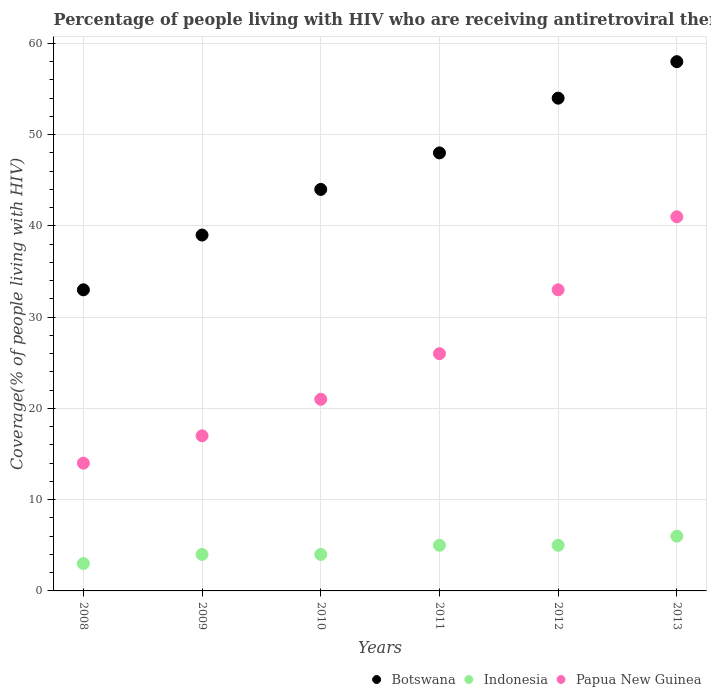How many different coloured dotlines are there?
Give a very brief answer. 3. What is the percentage of the HIV infected people who are receiving antiretroviral therapy in Indonesia in 2011?
Give a very brief answer. 5. Across all years, what is the maximum percentage of the HIV infected people who are receiving antiretroviral therapy in Papua New Guinea?
Provide a succinct answer. 41. Across all years, what is the minimum percentage of the HIV infected people who are receiving antiretroviral therapy in Indonesia?
Give a very brief answer. 3. What is the total percentage of the HIV infected people who are receiving antiretroviral therapy in Botswana in the graph?
Offer a very short reply. 276. What is the difference between the percentage of the HIV infected people who are receiving antiretroviral therapy in Indonesia in 2008 and that in 2012?
Offer a terse response. -2. What is the difference between the percentage of the HIV infected people who are receiving antiretroviral therapy in Indonesia in 2011 and the percentage of the HIV infected people who are receiving antiretroviral therapy in Botswana in 2010?
Ensure brevity in your answer.  -39. In the year 2008, what is the difference between the percentage of the HIV infected people who are receiving antiretroviral therapy in Indonesia and percentage of the HIV infected people who are receiving antiretroviral therapy in Botswana?
Offer a terse response. -30. What is the ratio of the percentage of the HIV infected people who are receiving antiretroviral therapy in Papua New Guinea in 2008 to that in 2010?
Your answer should be very brief. 0.67. Is the percentage of the HIV infected people who are receiving antiretroviral therapy in Botswana in 2010 less than that in 2011?
Ensure brevity in your answer.  Yes. Is the difference between the percentage of the HIV infected people who are receiving antiretroviral therapy in Indonesia in 2008 and 2009 greater than the difference between the percentage of the HIV infected people who are receiving antiretroviral therapy in Botswana in 2008 and 2009?
Offer a very short reply. Yes. What is the difference between the highest and the second highest percentage of the HIV infected people who are receiving antiretroviral therapy in Indonesia?
Ensure brevity in your answer.  1. What is the difference between the highest and the lowest percentage of the HIV infected people who are receiving antiretroviral therapy in Papua New Guinea?
Ensure brevity in your answer.  27. In how many years, is the percentage of the HIV infected people who are receiving antiretroviral therapy in Indonesia greater than the average percentage of the HIV infected people who are receiving antiretroviral therapy in Indonesia taken over all years?
Keep it short and to the point. 3. Is the sum of the percentage of the HIV infected people who are receiving antiretroviral therapy in Indonesia in 2009 and 2010 greater than the maximum percentage of the HIV infected people who are receiving antiretroviral therapy in Botswana across all years?
Offer a terse response. No. How many years are there in the graph?
Provide a short and direct response. 6. What is the difference between two consecutive major ticks on the Y-axis?
Your answer should be very brief. 10. Does the graph contain any zero values?
Your response must be concise. No. Where does the legend appear in the graph?
Your answer should be very brief. Bottom right. How many legend labels are there?
Offer a very short reply. 3. What is the title of the graph?
Your answer should be compact. Percentage of people living with HIV who are receiving antiretroviral therapy. Does "Costa Rica" appear as one of the legend labels in the graph?
Your answer should be compact. No. What is the label or title of the X-axis?
Provide a short and direct response. Years. What is the label or title of the Y-axis?
Offer a terse response. Coverage(% of people living with HIV). What is the Coverage(% of people living with HIV) of Botswana in 2008?
Keep it short and to the point. 33. What is the Coverage(% of people living with HIV) of Indonesia in 2008?
Offer a terse response. 3. What is the Coverage(% of people living with HIV) of Botswana in 2009?
Your response must be concise. 39. What is the Coverage(% of people living with HIV) of Indonesia in 2009?
Keep it short and to the point. 4. What is the Coverage(% of people living with HIV) in Botswana in 2010?
Your response must be concise. 44. What is the Coverage(% of people living with HIV) of Botswana in 2011?
Make the answer very short. 48. What is the Coverage(% of people living with HIV) in Botswana in 2012?
Make the answer very short. 54. What is the Coverage(% of people living with HIV) in Indonesia in 2012?
Keep it short and to the point. 5. What is the Coverage(% of people living with HIV) in Botswana in 2013?
Ensure brevity in your answer.  58. What is the Coverage(% of people living with HIV) in Indonesia in 2013?
Provide a short and direct response. 6. What is the Coverage(% of people living with HIV) in Papua New Guinea in 2013?
Your answer should be compact. 41. Across all years, what is the maximum Coverage(% of people living with HIV) in Botswana?
Your answer should be very brief. 58. Across all years, what is the minimum Coverage(% of people living with HIV) of Indonesia?
Provide a succinct answer. 3. What is the total Coverage(% of people living with HIV) in Botswana in the graph?
Provide a succinct answer. 276. What is the total Coverage(% of people living with HIV) in Papua New Guinea in the graph?
Offer a very short reply. 152. What is the difference between the Coverage(% of people living with HIV) in Indonesia in 2008 and that in 2010?
Keep it short and to the point. -1. What is the difference between the Coverage(% of people living with HIV) in Papua New Guinea in 2008 and that in 2011?
Your answer should be very brief. -12. What is the difference between the Coverage(% of people living with HIV) of Indonesia in 2008 and that in 2012?
Give a very brief answer. -2. What is the difference between the Coverage(% of people living with HIV) in Papua New Guinea in 2008 and that in 2012?
Your answer should be compact. -19. What is the difference between the Coverage(% of people living with HIV) of Indonesia in 2008 and that in 2013?
Your answer should be very brief. -3. What is the difference between the Coverage(% of people living with HIV) of Papua New Guinea in 2008 and that in 2013?
Give a very brief answer. -27. What is the difference between the Coverage(% of people living with HIV) of Botswana in 2009 and that in 2010?
Provide a succinct answer. -5. What is the difference between the Coverage(% of people living with HIV) of Botswana in 2009 and that in 2011?
Give a very brief answer. -9. What is the difference between the Coverage(% of people living with HIV) in Papua New Guinea in 2009 and that in 2011?
Provide a short and direct response. -9. What is the difference between the Coverage(% of people living with HIV) in Papua New Guinea in 2009 and that in 2012?
Offer a very short reply. -16. What is the difference between the Coverage(% of people living with HIV) of Botswana in 2009 and that in 2013?
Make the answer very short. -19. What is the difference between the Coverage(% of people living with HIV) of Botswana in 2010 and that in 2012?
Your answer should be compact. -10. What is the difference between the Coverage(% of people living with HIV) of Indonesia in 2010 and that in 2012?
Give a very brief answer. -1. What is the difference between the Coverage(% of people living with HIV) in Indonesia in 2010 and that in 2013?
Offer a very short reply. -2. What is the difference between the Coverage(% of people living with HIV) in Botswana in 2011 and that in 2012?
Provide a short and direct response. -6. What is the difference between the Coverage(% of people living with HIV) in Papua New Guinea in 2011 and that in 2012?
Your answer should be very brief. -7. What is the difference between the Coverage(% of people living with HIV) in Botswana in 2011 and that in 2013?
Provide a succinct answer. -10. What is the difference between the Coverage(% of people living with HIV) of Indonesia in 2011 and that in 2013?
Provide a short and direct response. -1. What is the difference between the Coverage(% of people living with HIV) of Botswana in 2012 and that in 2013?
Your answer should be compact. -4. What is the difference between the Coverage(% of people living with HIV) in Botswana in 2008 and the Coverage(% of people living with HIV) in Papua New Guinea in 2010?
Ensure brevity in your answer.  12. What is the difference between the Coverage(% of people living with HIV) of Indonesia in 2008 and the Coverage(% of people living with HIV) of Papua New Guinea in 2011?
Make the answer very short. -23. What is the difference between the Coverage(% of people living with HIV) in Botswana in 2008 and the Coverage(% of people living with HIV) in Indonesia in 2012?
Your answer should be very brief. 28. What is the difference between the Coverage(% of people living with HIV) of Indonesia in 2008 and the Coverage(% of people living with HIV) of Papua New Guinea in 2012?
Make the answer very short. -30. What is the difference between the Coverage(% of people living with HIV) of Botswana in 2008 and the Coverage(% of people living with HIV) of Papua New Guinea in 2013?
Your answer should be very brief. -8. What is the difference between the Coverage(% of people living with HIV) in Indonesia in 2008 and the Coverage(% of people living with HIV) in Papua New Guinea in 2013?
Your answer should be compact. -38. What is the difference between the Coverage(% of people living with HIV) in Botswana in 2009 and the Coverage(% of people living with HIV) in Indonesia in 2010?
Provide a short and direct response. 35. What is the difference between the Coverage(% of people living with HIV) of Botswana in 2009 and the Coverage(% of people living with HIV) of Papua New Guinea in 2010?
Offer a terse response. 18. What is the difference between the Coverage(% of people living with HIV) of Botswana in 2009 and the Coverage(% of people living with HIV) of Indonesia in 2011?
Provide a succinct answer. 34. What is the difference between the Coverage(% of people living with HIV) in Botswana in 2009 and the Coverage(% of people living with HIV) in Papua New Guinea in 2011?
Your answer should be compact. 13. What is the difference between the Coverage(% of people living with HIV) of Indonesia in 2009 and the Coverage(% of people living with HIV) of Papua New Guinea in 2011?
Provide a short and direct response. -22. What is the difference between the Coverage(% of people living with HIV) in Botswana in 2009 and the Coverage(% of people living with HIV) in Indonesia in 2012?
Offer a terse response. 34. What is the difference between the Coverage(% of people living with HIV) of Botswana in 2009 and the Coverage(% of people living with HIV) of Papua New Guinea in 2012?
Provide a short and direct response. 6. What is the difference between the Coverage(% of people living with HIV) of Botswana in 2009 and the Coverage(% of people living with HIV) of Papua New Guinea in 2013?
Keep it short and to the point. -2. What is the difference between the Coverage(% of people living with HIV) in Indonesia in 2009 and the Coverage(% of people living with HIV) in Papua New Guinea in 2013?
Your answer should be compact. -37. What is the difference between the Coverage(% of people living with HIV) in Botswana in 2010 and the Coverage(% of people living with HIV) in Indonesia in 2011?
Your response must be concise. 39. What is the difference between the Coverage(% of people living with HIV) of Indonesia in 2010 and the Coverage(% of people living with HIV) of Papua New Guinea in 2011?
Give a very brief answer. -22. What is the difference between the Coverage(% of people living with HIV) of Botswana in 2010 and the Coverage(% of people living with HIV) of Indonesia in 2012?
Make the answer very short. 39. What is the difference between the Coverage(% of people living with HIV) of Indonesia in 2010 and the Coverage(% of people living with HIV) of Papua New Guinea in 2012?
Provide a short and direct response. -29. What is the difference between the Coverage(% of people living with HIV) of Botswana in 2010 and the Coverage(% of people living with HIV) of Indonesia in 2013?
Ensure brevity in your answer.  38. What is the difference between the Coverage(% of people living with HIV) of Botswana in 2010 and the Coverage(% of people living with HIV) of Papua New Guinea in 2013?
Offer a very short reply. 3. What is the difference between the Coverage(% of people living with HIV) of Indonesia in 2010 and the Coverage(% of people living with HIV) of Papua New Guinea in 2013?
Offer a terse response. -37. What is the difference between the Coverage(% of people living with HIV) in Botswana in 2011 and the Coverage(% of people living with HIV) in Indonesia in 2012?
Give a very brief answer. 43. What is the difference between the Coverage(% of people living with HIV) in Botswana in 2011 and the Coverage(% of people living with HIV) in Papua New Guinea in 2013?
Your response must be concise. 7. What is the difference between the Coverage(% of people living with HIV) of Indonesia in 2011 and the Coverage(% of people living with HIV) of Papua New Guinea in 2013?
Provide a short and direct response. -36. What is the difference between the Coverage(% of people living with HIV) of Botswana in 2012 and the Coverage(% of people living with HIV) of Indonesia in 2013?
Your answer should be compact. 48. What is the difference between the Coverage(% of people living with HIV) of Indonesia in 2012 and the Coverage(% of people living with HIV) of Papua New Guinea in 2013?
Provide a succinct answer. -36. What is the average Coverage(% of people living with HIV) of Indonesia per year?
Your answer should be compact. 4.5. What is the average Coverage(% of people living with HIV) in Papua New Guinea per year?
Offer a very short reply. 25.33. In the year 2008, what is the difference between the Coverage(% of people living with HIV) of Indonesia and Coverage(% of people living with HIV) of Papua New Guinea?
Offer a very short reply. -11. In the year 2009, what is the difference between the Coverage(% of people living with HIV) of Botswana and Coverage(% of people living with HIV) of Indonesia?
Give a very brief answer. 35. In the year 2010, what is the difference between the Coverage(% of people living with HIV) in Botswana and Coverage(% of people living with HIV) in Papua New Guinea?
Give a very brief answer. 23. In the year 2011, what is the difference between the Coverage(% of people living with HIV) in Botswana and Coverage(% of people living with HIV) in Papua New Guinea?
Offer a terse response. 22. In the year 2012, what is the difference between the Coverage(% of people living with HIV) of Botswana and Coverage(% of people living with HIV) of Indonesia?
Give a very brief answer. 49. In the year 2013, what is the difference between the Coverage(% of people living with HIV) in Botswana and Coverage(% of people living with HIV) in Indonesia?
Provide a short and direct response. 52. In the year 2013, what is the difference between the Coverage(% of people living with HIV) in Indonesia and Coverage(% of people living with HIV) in Papua New Guinea?
Your answer should be compact. -35. What is the ratio of the Coverage(% of people living with HIV) in Botswana in 2008 to that in 2009?
Make the answer very short. 0.85. What is the ratio of the Coverage(% of people living with HIV) in Papua New Guinea in 2008 to that in 2009?
Make the answer very short. 0.82. What is the ratio of the Coverage(% of people living with HIV) of Botswana in 2008 to that in 2010?
Ensure brevity in your answer.  0.75. What is the ratio of the Coverage(% of people living with HIV) in Indonesia in 2008 to that in 2010?
Keep it short and to the point. 0.75. What is the ratio of the Coverage(% of people living with HIV) in Botswana in 2008 to that in 2011?
Make the answer very short. 0.69. What is the ratio of the Coverage(% of people living with HIV) of Papua New Guinea in 2008 to that in 2011?
Your response must be concise. 0.54. What is the ratio of the Coverage(% of people living with HIV) in Botswana in 2008 to that in 2012?
Keep it short and to the point. 0.61. What is the ratio of the Coverage(% of people living with HIV) in Indonesia in 2008 to that in 2012?
Provide a succinct answer. 0.6. What is the ratio of the Coverage(% of people living with HIV) of Papua New Guinea in 2008 to that in 2012?
Ensure brevity in your answer.  0.42. What is the ratio of the Coverage(% of people living with HIV) in Botswana in 2008 to that in 2013?
Your answer should be compact. 0.57. What is the ratio of the Coverage(% of people living with HIV) of Indonesia in 2008 to that in 2013?
Your answer should be compact. 0.5. What is the ratio of the Coverage(% of people living with HIV) in Papua New Guinea in 2008 to that in 2013?
Your answer should be very brief. 0.34. What is the ratio of the Coverage(% of people living with HIV) in Botswana in 2009 to that in 2010?
Your response must be concise. 0.89. What is the ratio of the Coverage(% of people living with HIV) of Indonesia in 2009 to that in 2010?
Provide a succinct answer. 1. What is the ratio of the Coverage(% of people living with HIV) of Papua New Guinea in 2009 to that in 2010?
Offer a terse response. 0.81. What is the ratio of the Coverage(% of people living with HIV) in Botswana in 2009 to that in 2011?
Offer a terse response. 0.81. What is the ratio of the Coverage(% of people living with HIV) of Papua New Guinea in 2009 to that in 2011?
Provide a succinct answer. 0.65. What is the ratio of the Coverage(% of people living with HIV) in Botswana in 2009 to that in 2012?
Your answer should be very brief. 0.72. What is the ratio of the Coverage(% of people living with HIV) in Papua New Guinea in 2009 to that in 2012?
Make the answer very short. 0.52. What is the ratio of the Coverage(% of people living with HIV) of Botswana in 2009 to that in 2013?
Keep it short and to the point. 0.67. What is the ratio of the Coverage(% of people living with HIV) in Papua New Guinea in 2009 to that in 2013?
Ensure brevity in your answer.  0.41. What is the ratio of the Coverage(% of people living with HIV) in Indonesia in 2010 to that in 2011?
Keep it short and to the point. 0.8. What is the ratio of the Coverage(% of people living with HIV) of Papua New Guinea in 2010 to that in 2011?
Your answer should be compact. 0.81. What is the ratio of the Coverage(% of people living with HIV) of Botswana in 2010 to that in 2012?
Offer a very short reply. 0.81. What is the ratio of the Coverage(% of people living with HIV) in Indonesia in 2010 to that in 2012?
Your answer should be very brief. 0.8. What is the ratio of the Coverage(% of people living with HIV) of Papua New Guinea in 2010 to that in 2012?
Ensure brevity in your answer.  0.64. What is the ratio of the Coverage(% of people living with HIV) of Botswana in 2010 to that in 2013?
Your response must be concise. 0.76. What is the ratio of the Coverage(% of people living with HIV) in Indonesia in 2010 to that in 2013?
Make the answer very short. 0.67. What is the ratio of the Coverage(% of people living with HIV) in Papua New Guinea in 2010 to that in 2013?
Your response must be concise. 0.51. What is the ratio of the Coverage(% of people living with HIV) in Indonesia in 2011 to that in 2012?
Give a very brief answer. 1. What is the ratio of the Coverage(% of people living with HIV) of Papua New Guinea in 2011 to that in 2012?
Provide a short and direct response. 0.79. What is the ratio of the Coverage(% of people living with HIV) of Botswana in 2011 to that in 2013?
Provide a succinct answer. 0.83. What is the ratio of the Coverage(% of people living with HIV) in Papua New Guinea in 2011 to that in 2013?
Provide a short and direct response. 0.63. What is the ratio of the Coverage(% of people living with HIV) of Indonesia in 2012 to that in 2013?
Make the answer very short. 0.83. What is the ratio of the Coverage(% of people living with HIV) in Papua New Guinea in 2012 to that in 2013?
Keep it short and to the point. 0.8. What is the difference between the highest and the lowest Coverage(% of people living with HIV) of Papua New Guinea?
Offer a terse response. 27. 